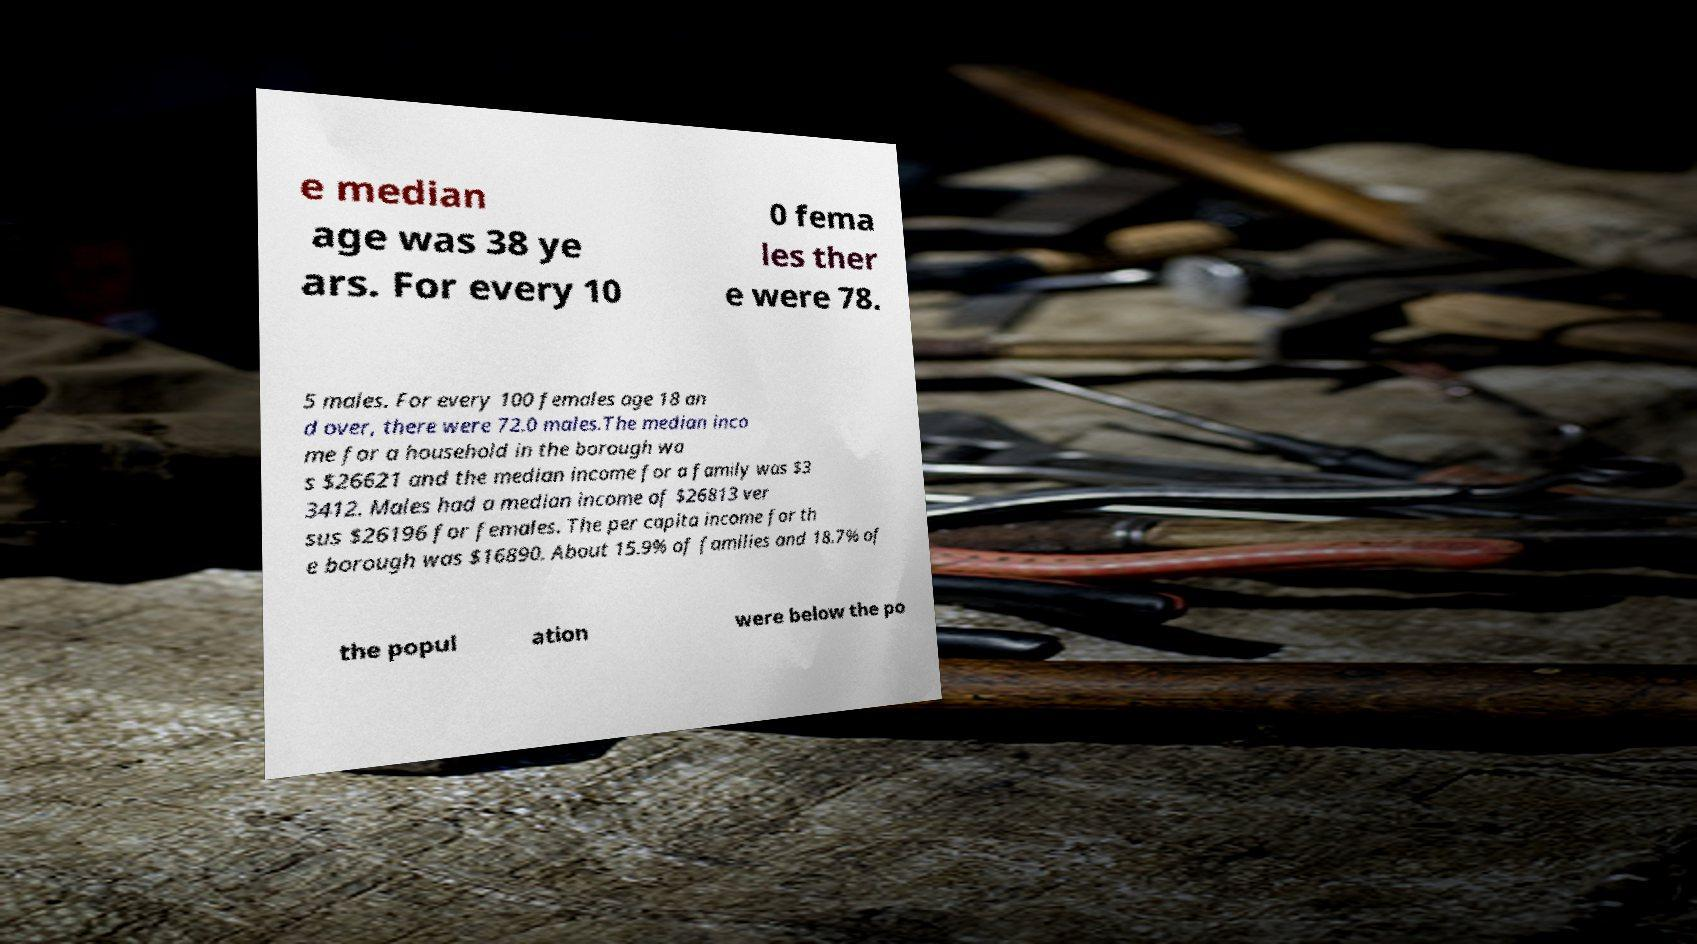I need the written content from this picture converted into text. Can you do that? e median age was 38 ye ars. For every 10 0 fema les ther e were 78. 5 males. For every 100 females age 18 an d over, there were 72.0 males.The median inco me for a household in the borough wa s $26621 and the median income for a family was $3 3412. Males had a median income of $26813 ver sus $26196 for females. The per capita income for th e borough was $16890. About 15.9% of families and 18.7% of the popul ation were below the po 